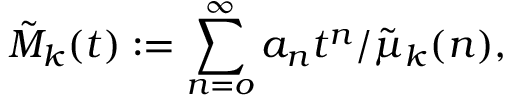Convert formula to latex. <formula><loc_0><loc_0><loc_500><loc_500>\tilde { M } _ { k } ( t ) \colon = \sum _ { n = o } ^ { \infty } a _ { n } t ^ { n } / \tilde { \mu } _ { k } ( n ) ,</formula> 